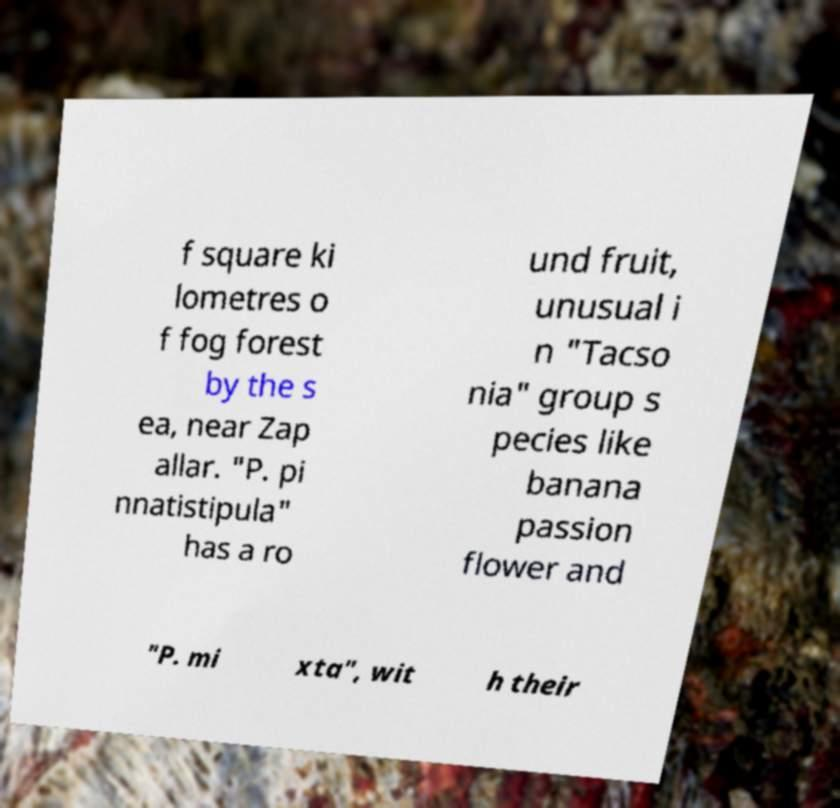Please read and relay the text visible in this image. What does it say? f square ki lometres o f fog forest by the s ea, near Zap allar. "P. pi nnatistipula" has a ro und fruit, unusual i n "Tacso nia" group s pecies like banana passion flower and "P. mi xta", wit h their 